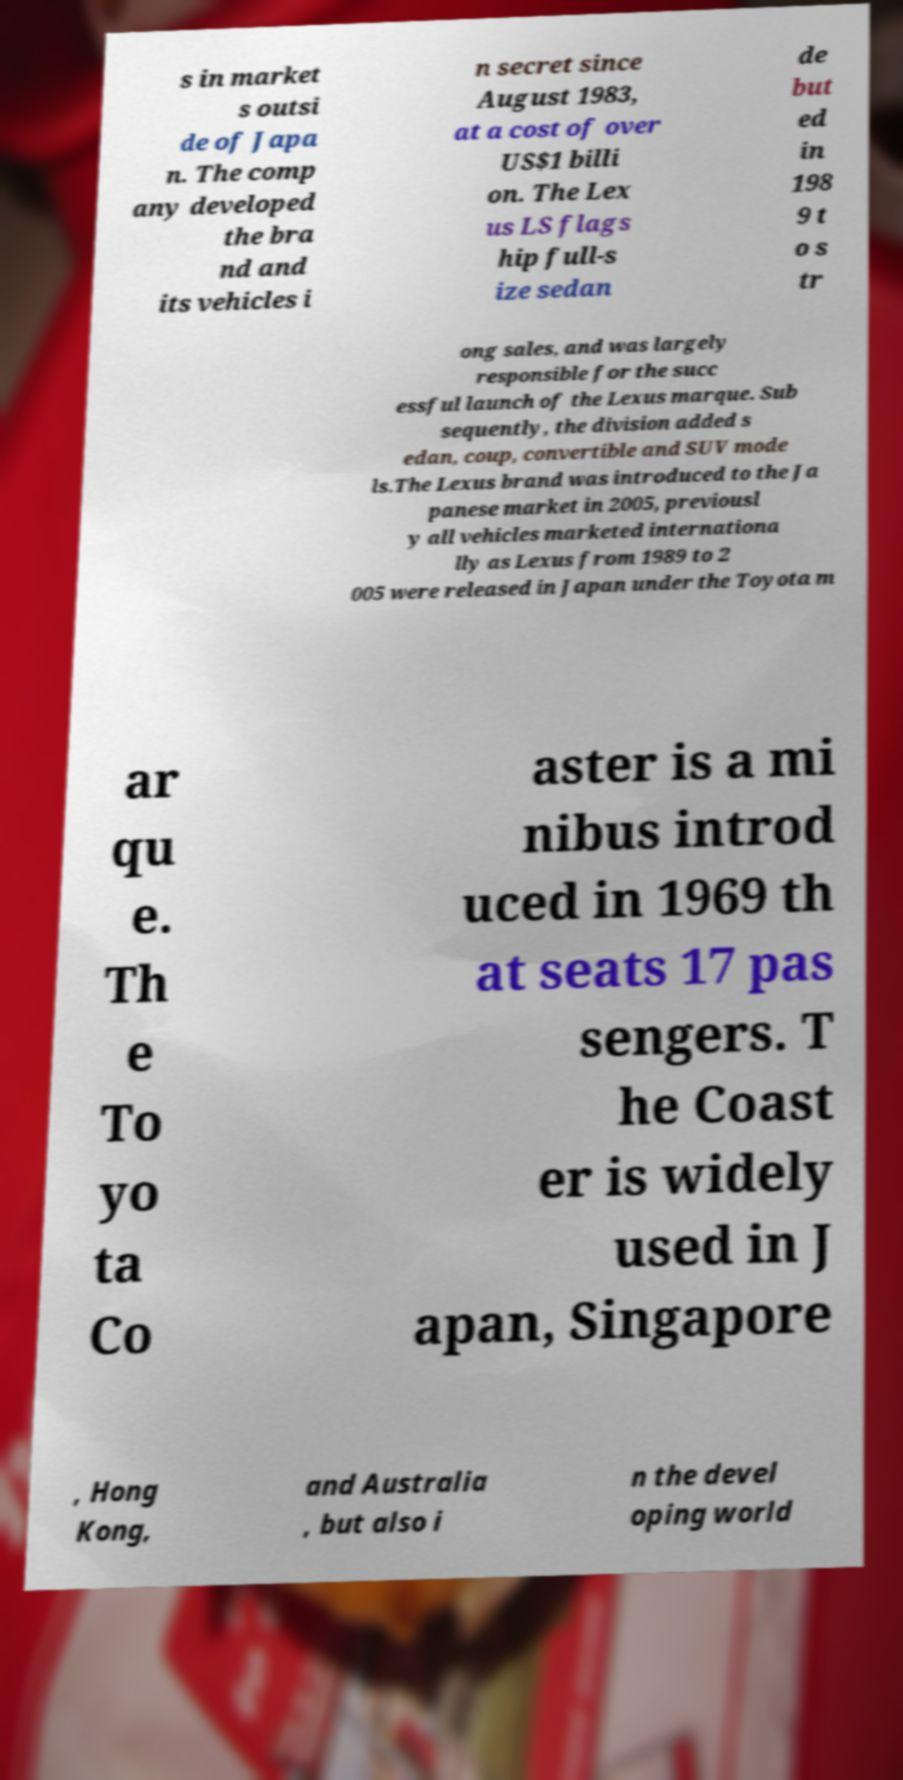For documentation purposes, I need the text within this image transcribed. Could you provide that? s in market s outsi de of Japa n. The comp any developed the bra nd and its vehicles i n secret since August 1983, at a cost of over US$1 billi on. The Lex us LS flags hip full-s ize sedan de but ed in 198 9 t o s tr ong sales, and was largely responsible for the succ essful launch of the Lexus marque. Sub sequently, the division added s edan, coup, convertible and SUV mode ls.The Lexus brand was introduced to the Ja panese market in 2005, previousl y all vehicles marketed internationa lly as Lexus from 1989 to 2 005 were released in Japan under the Toyota m ar qu e. Th e To yo ta Co aster is a mi nibus introd uced in 1969 th at seats 17 pas sengers. T he Coast er is widely used in J apan, Singapore , Hong Kong, and Australia , but also i n the devel oping world 